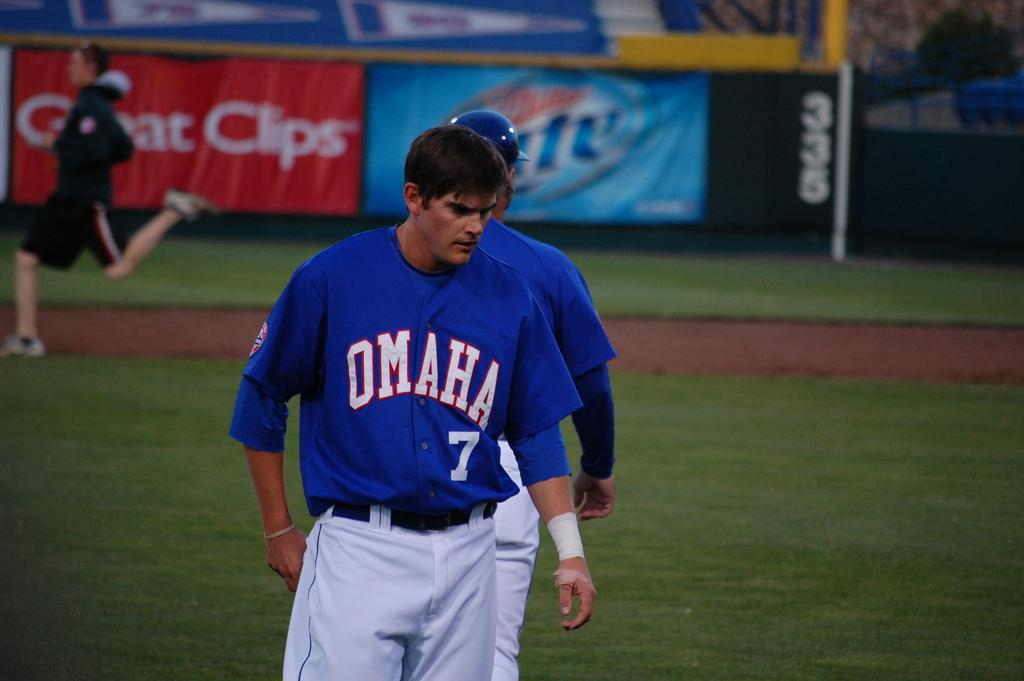<image>
Give a short and clear explanation of the subsequent image. A man wears a number 7 on his jersey, representing Omaha. 